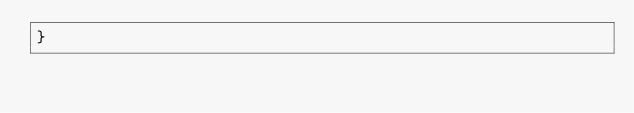<code> <loc_0><loc_0><loc_500><loc_500><_Java_>}
</code> 